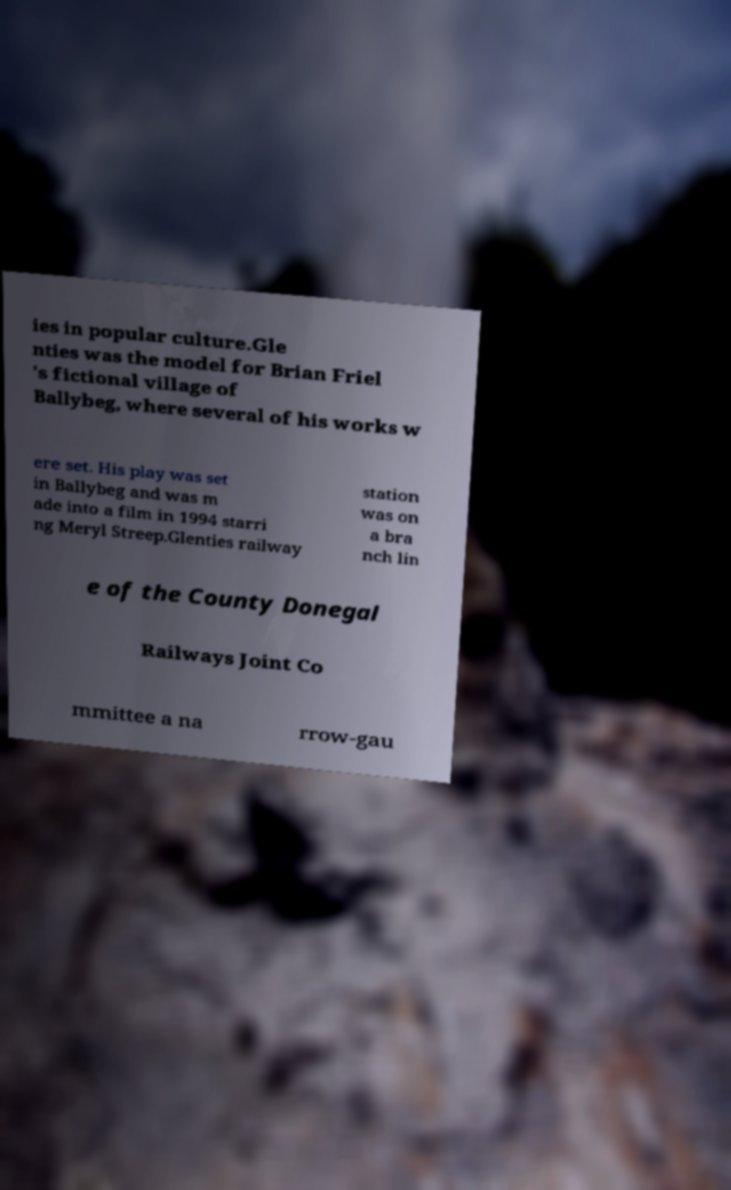For documentation purposes, I need the text within this image transcribed. Could you provide that? ies in popular culture.Gle nties was the model for Brian Friel 's fictional village of Ballybeg, where several of his works w ere set. His play was set in Ballybeg and was m ade into a film in 1994 starri ng Meryl Streep.Glenties railway station was on a bra nch lin e of the County Donegal Railways Joint Co mmittee a na rrow-gau 